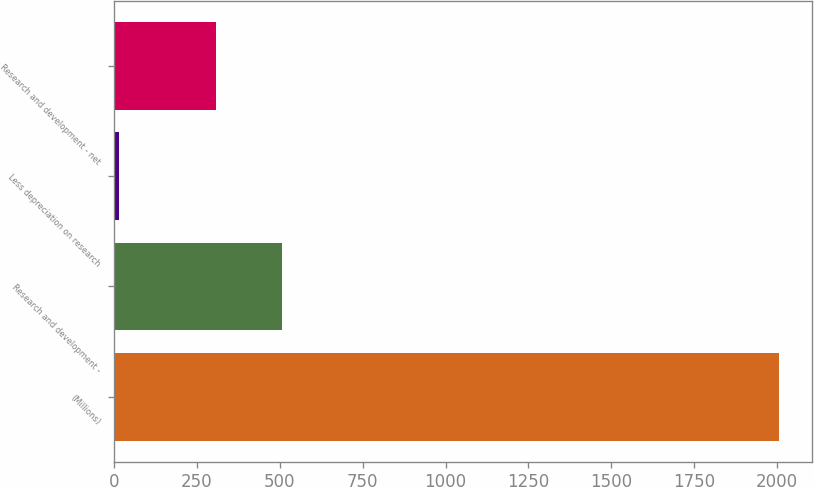Convert chart to OTSL. <chart><loc_0><loc_0><loc_500><loc_500><bar_chart><fcel>(Millions)<fcel>Research and development -<fcel>Less depreciation on research<fcel>Research and development - net<nl><fcel>2005<fcel>507.9<fcel>16<fcel>309<nl></chart> 